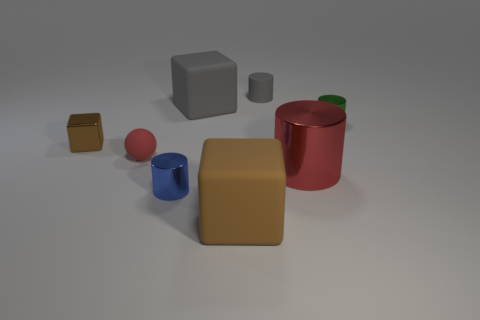Are the large cube that is behind the small brown block and the blue thing made of the same material?
Keep it short and to the point. No. Is there anything else that has the same material as the small brown thing?
Your response must be concise. Yes. How many things are in front of the big thing behind the tiny thing that is right of the large red metallic cylinder?
Your answer should be compact. 6. Is the shape of the tiny rubber object that is to the right of the small blue thing the same as  the large red thing?
Make the answer very short. Yes. How many things are large brown objects or brown cubes to the left of the red ball?
Your answer should be compact. 2. Are there more big matte objects right of the large red thing than tiny red balls?
Offer a terse response. No. Are there an equal number of brown metal cubes that are in front of the tiny red thing and brown objects to the right of the blue thing?
Provide a succinct answer. No. There is a red object to the right of the tiny gray cylinder; are there any large red cylinders in front of it?
Your answer should be very brief. No. The big metal thing has what shape?
Provide a short and direct response. Cylinder. There is a metal cylinder that is the same color as the rubber ball; what is its size?
Give a very brief answer. Large. 